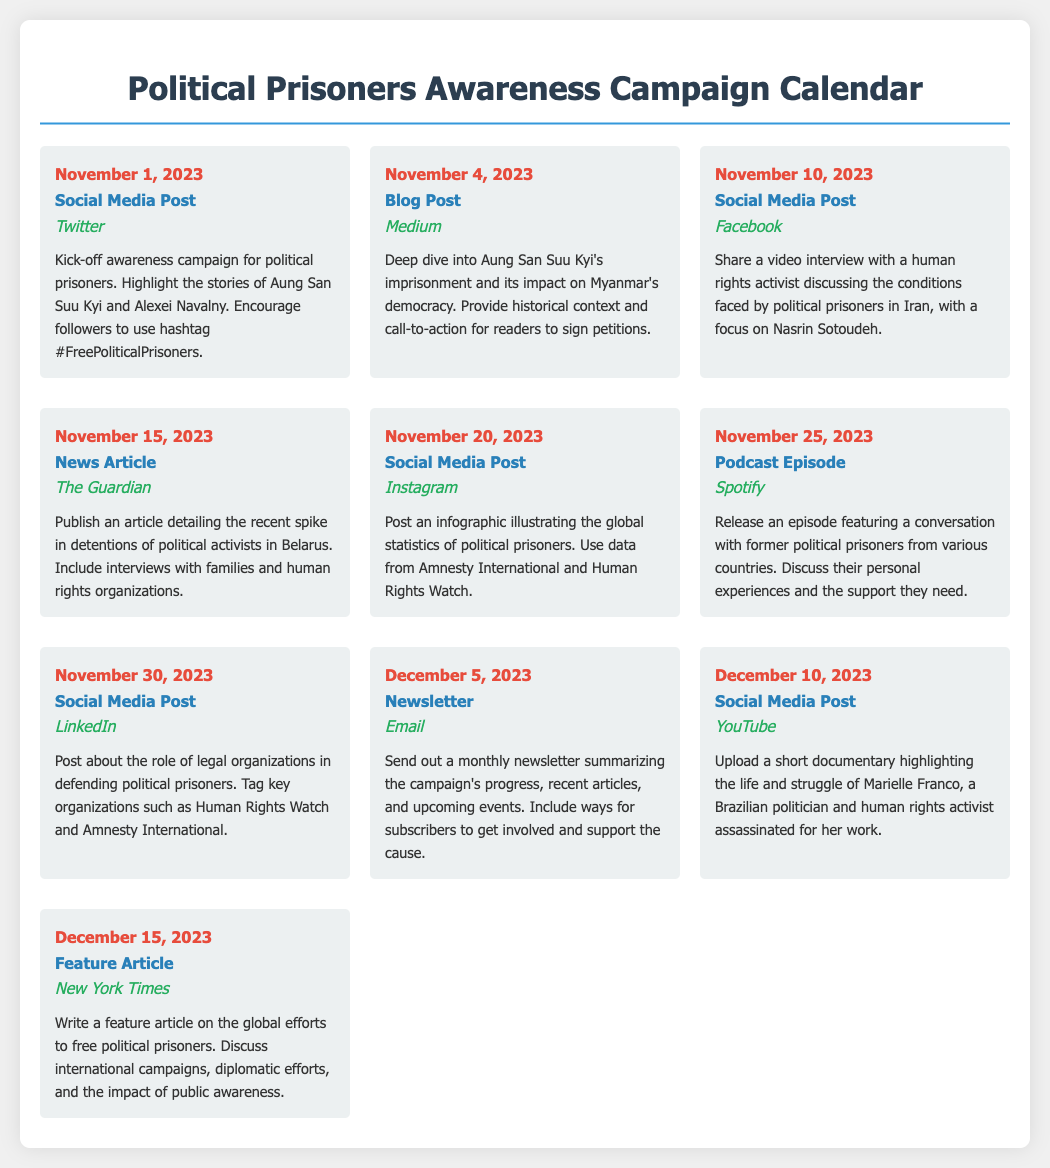What is the first date mentioned in the campaign calendar? The first date mentioned in the campaign calendar is November 1, 2023.
Answer: November 1, 2023 Which social media platform is used for the video interview about Nasrin Sotoudeh? The social media platform used for the video interview is Facebook.
Answer: Facebook How many total events are listed in the calendar? The document lists a total of ten events.
Answer: Ten What type of content will be released on November 25, 2023? The content to be released is a podcast episode.
Answer: Podcast Episode Which article features a discussion about the global efforts to free political prisoners? The article featuring this discussion is a feature article in the New York Times.
Answer: New York Times On which date is the social media post highlighting Marielle Franco scheduled? The social media post highlighting Marielle Franco is scheduled for December 10, 2023.
Answer: December 10, 2023 What is the main activity planned for November 4, 2023? The main activity planned for this date is a blog post.
Answer: Blog Post Which organization is mentioned in the social media post on November 30, 2023? The organization mentioned is Amnesty International.
Answer: Amnesty International What platform will the awareness campaign's newsletter be sent through on December 5, 2023? The newsletter will be sent through Email.
Answer: Email 